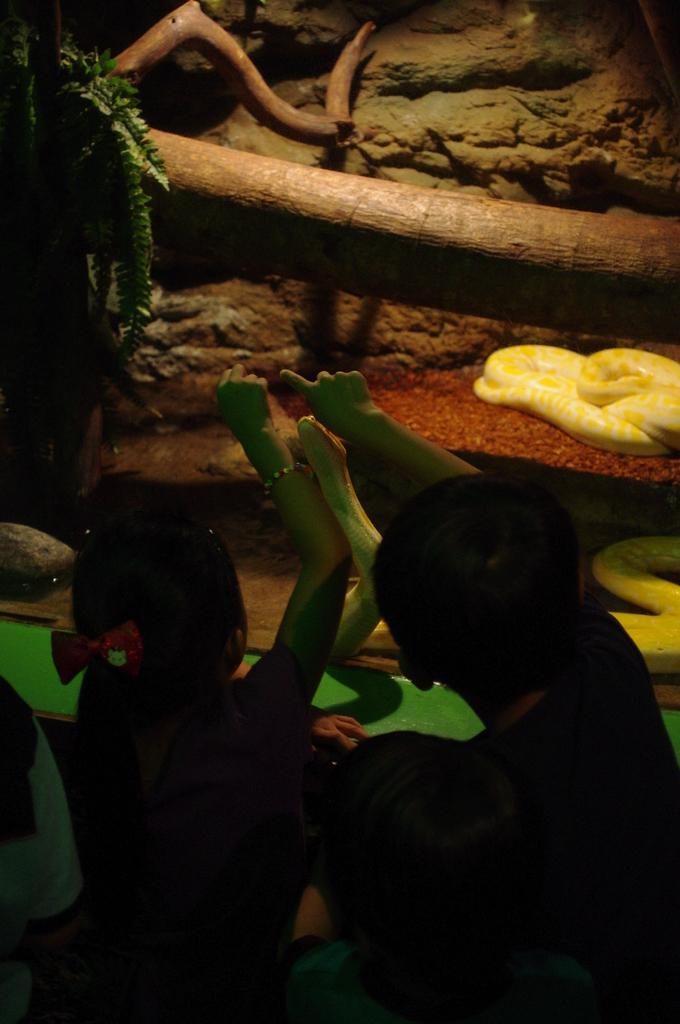What can be seen in the image involving living beings? There are people standing in the image. Are there any animals present in the image? Yes, there is a snake in the image. What type of vegetation is visible in the image? There is a plant in the image. What property does the snake own in the image? There is no indication in the image that the snake owns any property. 